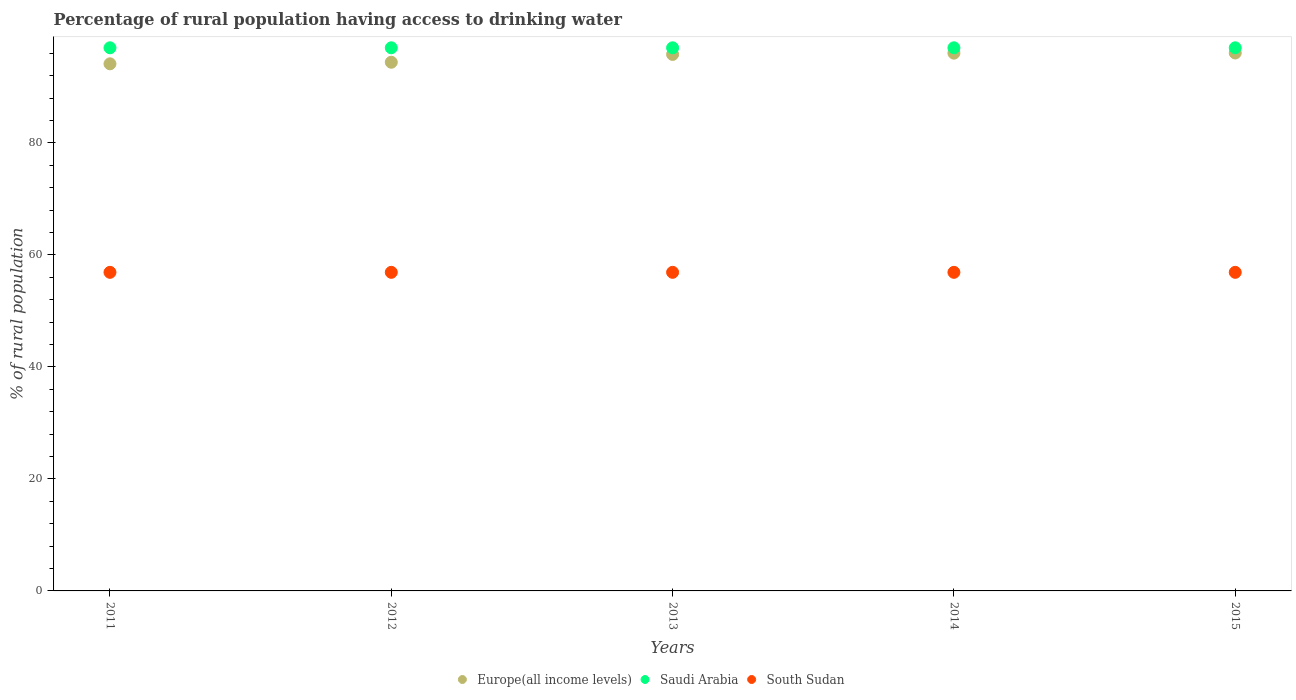How many different coloured dotlines are there?
Provide a succinct answer. 3. What is the percentage of rural population having access to drinking water in Saudi Arabia in 2014?
Offer a terse response. 97. Across all years, what is the maximum percentage of rural population having access to drinking water in Europe(all income levels)?
Your answer should be compact. 96.07. Across all years, what is the minimum percentage of rural population having access to drinking water in Saudi Arabia?
Ensure brevity in your answer.  97. In which year was the percentage of rural population having access to drinking water in South Sudan maximum?
Your answer should be compact. 2011. What is the total percentage of rural population having access to drinking water in Europe(all income levels) in the graph?
Give a very brief answer. 476.49. What is the difference between the percentage of rural population having access to drinking water in Saudi Arabia in 2014 and that in 2015?
Make the answer very short. 0. What is the difference between the percentage of rural population having access to drinking water in Saudi Arabia in 2011 and the percentage of rural population having access to drinking water in Europe(all income levels) in 2015?
Offer a very short reply. 0.93. What is the average percentage of rural population having access to drinking water in South Sudan per year?
Your answer should be compact. 56.9. In the year 2011, what is the difference between the percentage of rural population having access to drinking water in Europe(all income levels) and percentage of rural population having access to drinking water in South Sudan?
Make the answer very short. 37.24. Is the difference between the percentage of rural population having access to drinking water in Europe(all income levels) in 2012 and 2015 greater than the difference between the percentage of rural population having access to drinking water in South Sudan in 2012 and 2015?
Provide a succinct answer. No. What is the difference between the highest and the second highest percentage of rural population having access to drinking water in Saudi Arabia?
Your answer should be compact. 0. What is the difference between the highest and the lowest percentage of rural population having access to drinking water in Saudi Arabia?
Your response must be concise. 0. In how many years, is the percentage of rural population having access to drinking water in Saudi Arabia greater than the average percentage of rural population having access to drinking water in Saudi Arabia taken over all years?
Your answer should be very brief. 0. Is the sum of the percentage of rural population having access to drinking water in Europe(all income levels) in 2011 and 2013 greater than the maximum percentage of rural population having access to drinking water in South Sudan across all years?
Your answer should be compact. Yes. Is it the case that in every year, the sum of the percentage of rural population having access to drinking water in Europe(all income levels) and percentage of rural population having access to drinking water in South Sudan  is greater than the percentage of rural population having access to drinking water in Saudi Arabia?
Provide a short and direct response. Yes. Does the percentage of rural population having access to drinking water in Saudi Arabia monotonically increase over the years?
Your answer should be compact. No. Is the percentage of rural population having access to drinking water in Europe(all income levels) strictly less than the percentage of rural population having access to drinking water in Saudi Arabia over the years?
Your answer should be very brief. Yes. Does the graph contain grids?
Provide a succinct answer. No. Where does the legend appear in the graph?
Provide a succinct answer. Bottom center. How are the legend labels stacked?
Your answer should be compact. Horizontal. What is the title of the graph?
Your answer should be compact. Percentage of rural population having access to drinking water. What is the label or title of the X-axis?
Provide a short and direct response. Years. What is the label or title of the Y-axis?
Offer a very short reply. % of rural population. What is the % of rural population in Europe(all income levels) in 2011?
Provide a succinct answer. 94.14. What is the % of rural population in Saudi Arabia in 2011?
Offer a very short reply. 97. What is the % of rural population in South Sudan in 2011?
Give a very brief answer. 56.9. What is the % of rural population in Europe(all income levels) in 2012?
Ensure brevity in your answer.  94.42. What is the % of rural population of Saudi Arabia in 2012?
Give a very brief answer. 97. What is the % of rural population of South Sudan in 2012?
Give a very brief answer. 56.9. What is the % of rural population of Europe(all income levels) in 2013?
Keep it short and to the point. 95.81. What is the % of rural population of Saudi Arabia in 2013?
Provide a short and direct response. 97. What is the % of rural population of South Sudan in 2013?
Your answer should be compact. 56.9. What is the % of rural population in Europe(all income levels) in 2014?
Offer a very short reply. 96.04. What is the % of rural population in Saudi Arabia in 2014?
Offer a terse response. 97. What is the % of rural population of South Sudan in 2014?
Your answer should be very brief. 56.9. What is the % of rural population of Europe(all income levels) in 2015?
Offer a terse response. 96.07. What is the % of rural population of Saudi Arabia in 2015?
Provide a succinct answer. 97. What is the % of rural population in South Sudan in 2015?
Your answer should be compact. 56.9. Across all years, what is the maximum % of rural population in Europe(all income levels)?
Keep it short and to the point. 96.07. Across all years, what is the maximum % of rural population in Saudi Arabia?
Provide a short and direct response. 97. Across all years, what is the maximum % of rural population of South Sudan?
Offer a very short reply. 56.9. Across all years, what is the minimum % of rural population in Europe(all income levels)?
Give a very brief answer. 94.14. Across all years, what is the minimum % of rural population in Saudi Arabia?
Keep it short and to the point. 97. Across all years, what is the minimum % of rural population of South Sudan?
Offer a terse response. 56.9. What is the total % of rural population in Europe(all income levels) in the graph?
Your answer should be compact. 476.49. What is the total % of rural population in Saudi Arabia in the graph?
Your answer should be very brief. 485. What is the total % of rural population of South Sudan in the graph?
Give a very brief answer. 284.5. What is the difference between the % of rural population of Europe(all income levels) in 2011 and that in 2012?
Offer a terse response. -0.28. What is the difference between the % of rural population of South Sudan in 2011 and that in 2012?
Offer a very short reply. 0. What is the difference between the % of rural population of Europe(all income levels) in 2011 and that in 2013?
Provide a succinct answer. -1.68. What is the difference between the % of rural population in Saudi Arabia in 2011 and that in 2013?
Provide a short and direct response. 0. What is the difference between the % of rural population in South Sudan in 2011 and that in 2013?
Keep it short and to the point. 0. What is the difference between the % of rural population of Europe(all income levels) in 2011 and that in 2014?
Offer a very short reply. -1.9. What is the difference between the % of rural population in Saudi Arabia in 2011 and that in 2014?
Keep it short and to the point. 0. What is the difference between the % of rural population of Europe(all income levels) in 2011 and that in 2015?
Provide a succinct answer. -1.93. What is the difference between the % of rural population in Europe(all income levels) in 2012 and that in 2013?
Make the answer very short. -1.39. What is the difference between the % of rural population of Saudi Arabia in 2012 and that in 2013?
Ensure brevity in your answer.  0. What is the difference between the % of rural population in Europe(all income levels) in 2012 and that in 2014?
Offer a terse response. -1.62. What is the difference between the % of rural population in Saudi Arabia in 2012 and that in 2014?
Your answer should be very brief. 0. What is the difference between the % of rural population of South Sudan in 2012 and that in 2014?
Offer a very short reply. 0. What is the difference between the % of rural population in Europe(all income levels) in 2012 and that in 2015?
Ensure brevity in your answer.  -1.65. What is the difference between the % of rural population in South Sudan in 2012 and that in 2015?
Offer a very short reply. 0. What is the difference between the % of rural population in Europe(all income levels) in 2013 and that in 2014?
Offer a terse response. -0.23. What is the difference between the % of rural population of Saudi Arabia in 2013 and that in 2014?
Give a very brief answer. 0. What is the difference between the % of rural population in South Sudan in 2013 and that in 2014?
Ensure brevity in your answer.  0. What is the difference between the % of rural population of Europe(all income levels) in 2013 and that in 2015?
Your response must be concise. -0.26. What is the difference between the % of rural population in Saudi Arabia in 2013 and that in 2015?
Provide a succinct answer. 0. What is the difference between the % of rural population in Europe(all income levels) in 2014 and that in 2015?
Your answer should be compact. -0.03. What is the difference between the % of rural population of South Sudan in 2014 and that in 2015?
Offer a terse response. 0. What is the difference between the % of rural population in Europe(all income levels) in 2011 and the % of rural population in Saudi Arabia in 2012?
Give a very brief answer. -2.86. What is the difference between the % of rural population of Europe(all income levels) in 2011 and the % of rural population of South Sudan in 2012?
Your answer should be very brief. 37.24. What is the difference between the % of rural population in Saudi Arabia in 2011 and the % of rural population in South Sudan in 2012?
Provide a succinct answer. 40.1. What is the difference between the % of rural population of Europe(all income levels) in 2011 and the % of rural population of Saudi Arabia in 2013?
Provide a succinct answer. -2.86. What is the difference between the % of rural population in Europe(all income levels) in 2011 and the % of rural population in South Sudan in 2013?
Your answer should be very brief. 37.24. What is the difference between the % of rural population of Saudi Arabia in 2011 and the % of rural population of South Sudan in 2013?
Offer a very short reply. 40.1. What is the difference between the % of rural population in Europe(all income levels) in 2011 and the % of rural population in Saudi Arabia in 2014?
Give a very brief answer. -2.86. What is the difference between the % of rural population in Europe(all income levels) in 2011 and the % of rural population in South Sudan in 2014?
Keep it short and to the point. 37.24. What is the difference between the % of rural population of Saudi Arabia in 2011 and the % of rural population of South Sudan in 2014?
Offer a terse response. 40.1. What is the difference between the % of rural population of Europe(all income levels) in 2011 and the % of rural population of Saudi Arabia in 2015?
Ensure brevity in your answer.  -2.86. What is the difference between the % of rural population in Europe(all income levels) in 2011 and the % of rural population in South Sudan in 2015?
Provide a short and direct response. 37.24. What is the difference between the % of rural population in Saudi Arabia in 2011 and the % of rural population in South Sudan in 2015?
Keep it short and to the point. 40.1. What is the difference between the % of rural population of Europe(all income levels) in 2012 and the % of rural population of Saudi Arabia in 2013?
Ensure brevity in your answer.  -2.58. What is the difference between the % of rural population of Europe(all income levels) in 2012 and the % of rural population of South Sudan in 2013?
Provide a short and direct response. 37.52. What is the difference between the % of rural population of Saudi Arabia in 2012 and the % of rural population of South Sudan in 2013?
Offer a terse response. 40.1. What is the difference between the % of rural population in Europe(all income levels) in 2012 and the % of rural population in Saudi Arabia in 2014?
Make the answer very short. -2.58. What is the difference between the % of rural population of Europe(all income levels) in 2012 and the % of rural population of South Sudan in 2014?
Ensure brevity in your answer.  37.52. What is the difference between the % of rural population in Saudi Arabia in 2012 and the % of rural population in South Sudan in 2014?
Keep it short and to the point. 40.1. What is the difference between the % of rural population in Europe(all income levels) in 2012 and the % of rural population in Saudi Arabia in 2015?
Give a very brief answer. -2.58. What is the difference between the % of rural population of Europe(all income levels) in 2012 and the % of rural population of South Sudan in 2015?
Your response must be concise. 37.52. What is the difference between the % of rural population of Saudi Arabia in 2012 and the % of rural population of South Sudan in 2015?
Provide a short and direct response. 40.1. What is the difference between the % of rural population of Europe(all income levels) in 2013 and the % of rural population of Saudi Arabia in 2014?
Give a very brief answer. -1.19. What is the difference between the % of rural population in Europe(all income levels) in 2013 and the % of rural population in South Sudan in 2014?
Make the answer very short. 38.91. What is the difference between the % of rural population in Saudi Arabia in 2013 and the % of rural population in South Sudan in 2014?
Give a very brief answer. 40.1. What is the difference between the % of rural population of Europe(all income levels) in 2013 and the % of rural population of Saudi Arabia in 2015?
Give a very brief answer. -1.19. What is the difference between the % of rural population of Europe(all income levels) in 2013 and the % of rural population of South Sudan in 2015?
Keep it short and to the point. 38.91. What is the difference between the % of rural population of Saudi Arabia in 2013 and the % of rural population of South Sudan in 2015?
Make the answer very short. 40.1. What is the difference between the % of rural population of Europe(all income levels) in 2014 and the % of rural population of Saudi Arabia in 2015?
Offer a very short reply. -0.96. What is the difference between the % of rural population in Europe(all income levels) in 2014 and the % of rural population in South Sudan in 2015?
Your answer should be very brief. 39.14. What is the difference between the % of rural population of Saudi Arabia in 2014 and the % of rural population of South Sudan in 2015?
Your answer should be compact. 40.1. What is the average % of rural population of Europe(all income levels) per year?
Give a very brief answer. 95.3. What is the average % of rural population in Saudi Arabia per year?
Ensure brevity in your answer.  97. What is the average % of rural population of South Sudan per year?
Provide a succinct answer. 56.9. In the year 2011, what is the difference between the % of rural population of Europe(all income levels) and % of rural population of Saudi Arabia?
Give a very brief answer. -2.86. In the year 2011, what is the difference between the % of rural population of Europe(all income levels) and % of rural population of South Sudan?
Offer a very short reply. 37.24. In the year 2011, what is the difference between the % of rural population of Saudi Arabia and % of rural population of South Sudan?
Your answer should be very brief. 40.1. In the year 2012, what is the difference between the % of rural population in Europe(all income levels) and % of rural population in Saudi Arabia?
Provide a succinct answer. -2.58. In the year 2012, what is the difference between the % of rural population of Europe(all income levels) and % of rural population of South Sudan?
Offer a terse response. 37.52. In the year 2012, what is the difference between the % of rural population of Saudi Arabia and % of rural population of South Sudan?
Keep it short and to the point. 40.1. In the year 2013, what is the difference between the % of rural population of Europe(all income levels) and % of rural population of Saudi Arabia?
Offer a very short reply. -1.19. In the year 2013, what is the difference between the % of rural population in Europe(all income levels) and % of rural population in South Sudan?
Ensure brevity in your answer.  38.91. In the year 2013, what is the difference between the % of rural population in Saudi Arabia and % of rural population in South Sudan?
Your response must be concise. 40.1. In the year 2014, what is the difference between the % of rural population of Europe(all income levels) and % of rural population of Saudi Arabia?
Keep it short and to the point. -0.96. In the year 2014, what is the difference between the % of rural population in Europe(all income levels) and % of rural population in South Sudan?
Make the answer very short. 39.14. In the year 2014, what is the difference between the % of rural population in Saudi Arabia and % of rural population in South Sudan?
Your answer should be very brief. 40.1. In the year 2015, what is the difference between the % of rural population in Europe(all income levels) and % of rural population in Saudi Arabia?
Your answer should be very brief. -0.93. In the year 2015, what is the difference between the % of rural population of Europe(all income levels) and % of rural population of South Sudan?
Your response must be concise. 39.17. In the year 2015, what is the difference between the % of rural population in Saudi Arabia and % of rural population in South Sudan?
Offer a very short reply. 40.1. What is the ratio of the % of rural population of Saudi Arabia in 2011 to that in 2012?
Your answer should be very brief. 1. What is the ratio of the % of rural population in Europe(all income levels) in 2011 to that in 2013?
Your answer should be very brief. 0.98. What is the ratio of the % of rural population of Saudi Arabia in 2011 to that in 2013?
Your response must be concise. 1. What is the ratio of the % of rural population of Europe(all income levels) in 2011 to that in 2014?
Ensure brevity in your answer.  0.98. What is the ratio of the % of rural population of South Sudan in 2011 to that in 2014?
Offer a very short reply. 1. What is the ratio of the % of rural population of Europe(all income levels) in 2011 to that in 2015?
Offer a very short reply. 0.98. What is the ratio of the % of rural population in Europe(all income levels) in 2012 to that in 2013?
Your response must be concise. 0.99. What is the ratio of the % of rural population of Saudi Arabia in 2012 to that in 2013?
Provide a short and direct response. 1. What is the ratio of the % of rural population of South Sudan in 2012 to that in 2013?
Make the answer very short. 1. What is the ratio of the % of rural population of Europe(all income levels) in 2012 to that in 2014?
Provide a short and direct response. 0.98. What is the ratio of the % of rural population of Europe(all income levels) in 2012 to that in 2015?
Your response must be concise. 0.98. What is the ratio of the % of rural population in Saudi Arabia in 2012 to that in 2015?
Offer a terse response. 1. What is the ratio of the % of rural population in South Sudan in 2012 to that in 2015?
Give a very brief answer. 1. What is the ratio of the % of rural population in Europe(all income levels) in 2013 to that in 2014?
Your answer should be very brief. 1. What is the ratio of the % of rural population of Saudi Arabia in 2013 to that in 2014?
Make the answer very short. 1. What is the ratio of the % of rural population of South Sudan in 2013 to that in 2014?
Keep it short and to the point. 1. What is the ratio of the % of rural population of Europe(all income levels) in 2013 to that in 2015?
Give a very brief answer. 1. What is the ratio of the % of rural population of Europe(all income levels) in 2014 to that in 2015?
Offer a terse response. 1. What is the ratio of the % of rural population of Saudi Arabia in 2014 to that in 2015?
Your response must be concise. 1. What is the difference between the highest and the second highest % of rural population in Europe(all income levels)?
Offer a very short reply. 0.03. What is the difference between the highest and the second highest % of rural population in Saudi Arabia?
Provide a succinct answer. 0. What is the difference between the highest and the second highest % of rural population of South Sudan?
Ensure brevity in your answer.  0. What is the difference between the highest and the lowest % of rural population of Europe(all income levels)?
Provide a succinct answer. 1.93. What is the difference between the highest and the lowest % of rural population in South Sudan?
Give a very brief answer. 0. 